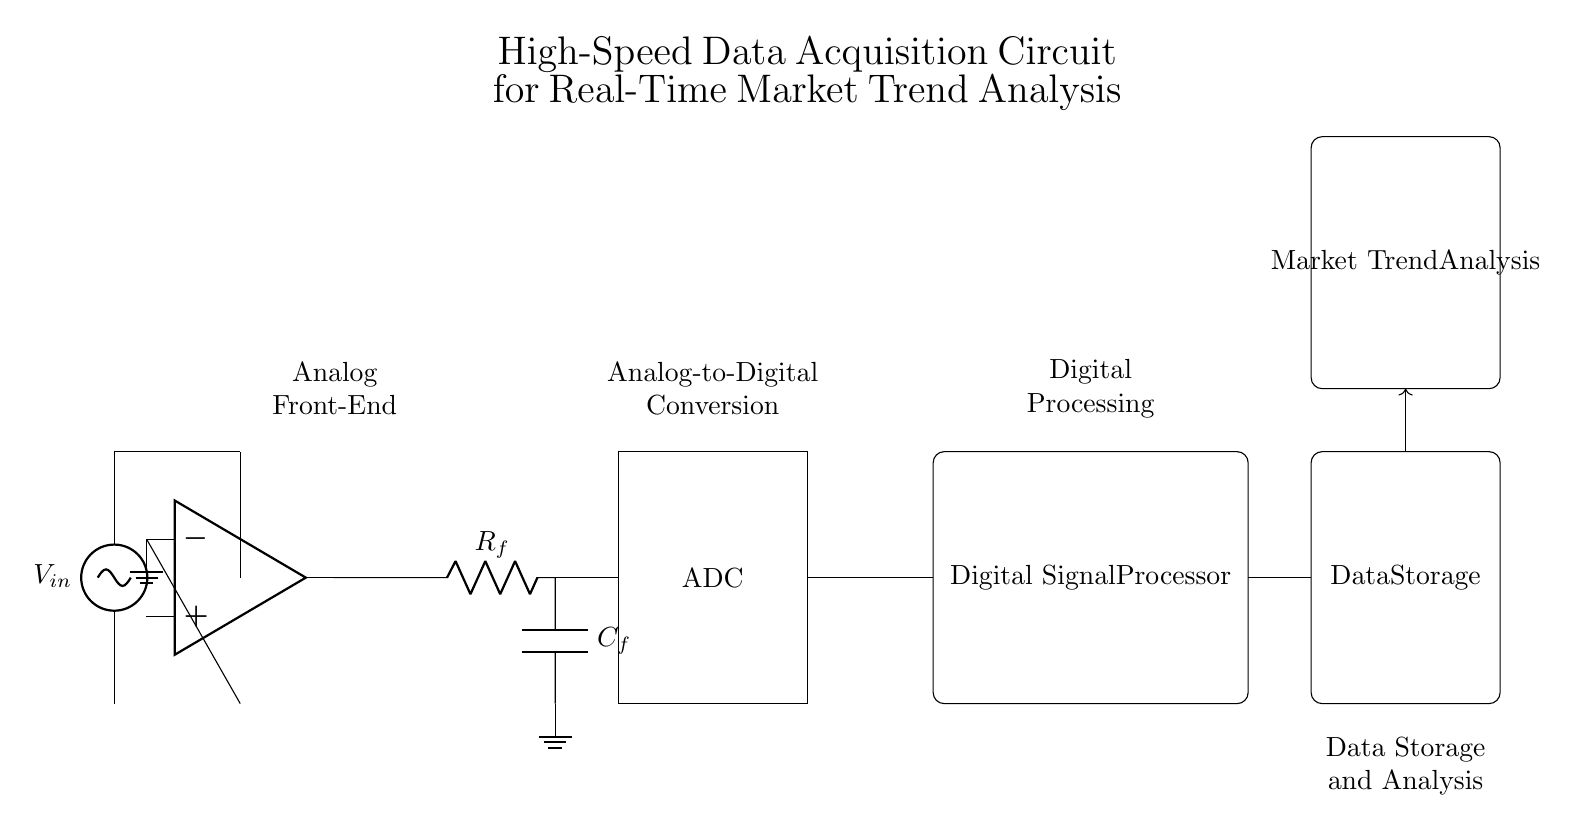What is the purpose of the amplifier in this circuit? The amplifier boosts the input signal voltage to a level that is suitable for further processing. This is essential to ensure that the subsequent components, such as the analog-to-digital converter, can accurately process the signal without losing information due to low amplitude.
Answer: Amplification What type of filter is used in this circuit? The low-pass filter allows low-frequency signals to pass while attenuating high-frequency signals, which helps to reduce noise and improve the quality of the signal before it reaches the analog-to-digital converter.
Answer: Low-pass filter What is the role of the ADC in the circuit? The analog-to-digital converter (ADC) converts the amplified analog signals into digital signals that can be processed by the digital signal processor, enabling the system to perform digital signal analysis and processing for market trend analysis.
Answer: Analog-to-digital conversion What component comes after the ADC in the signal path? The component immediately following the ADC is the digital signal processor, which processes the digitized signals for analysis and trend detection.
Answer: Digital Signal Processor What type of analysis is performed after data storage? After data storage, market trend analysis is performed to extract insights and trends from the stored data to inform decision-making processes in market research.
Answer: Market Trend Analysis How many main functional blocks are present in the circuit? The circuit has four main functional blocks: Analog Front-End, Analog-to-Digital Conversion, Digital Processing, and Data Storage and Analysis. Identifying these blocks helps to understand the flow of data and processing in the circuit.
Answer: Four functional blocks What is connected to ground in the circuit? The ground connection is made at the negative terminal of the amplifier, and there is also a ground connection on the capacitor of the low-pass filter. This establishes a reference point for all voltages in the circuit and completes the circuit paths.
Answer: Negative terminal of the amplifier and low-pass filter capacitor 